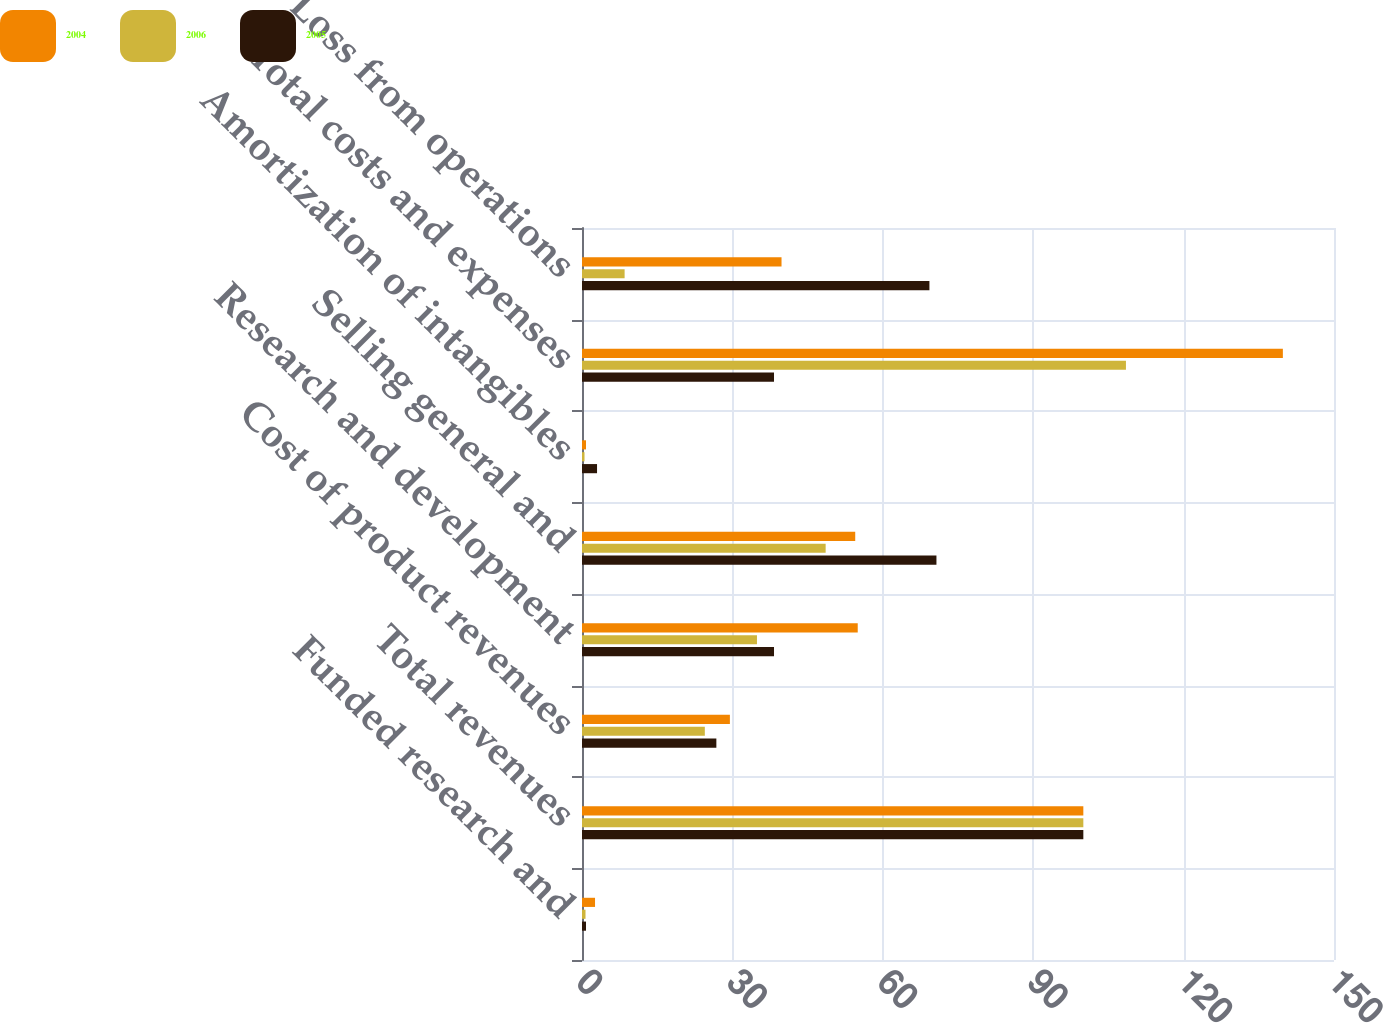Convert chart to OTSL. <chart><loc_0><loc_0><loc_500><loc_500><stacked_bar_chart><ecel><fcel>Funded research and<fcel>Total revenues<fcel>Cost of product revenues<fcel>Research and development<fcel>Selling general and<fcel>Amortization of intangibles<fcel>Total costs and expenses<fcel>Loss from operations<nl><fcel>2004<fcel>2.6<fcel>100<fcel>29.5<fcel>55<fcel>54.5<fcel>0.8<fcel>139.8<fcel>39.8<nl><fcel>2006<fcel>0.7<fcel>100<fcel>24.5<fcel>34.9<fcel>48.6<fcel>0.5<fcel>108.5<fcel>8.5<nl><fcel>2005<fcel>0.8<fcel>100<fcel>26.8<fcel>38.3<fcel>70.7<fcel>3<fcel>38.3<fcel>69.3<nl></chart> 